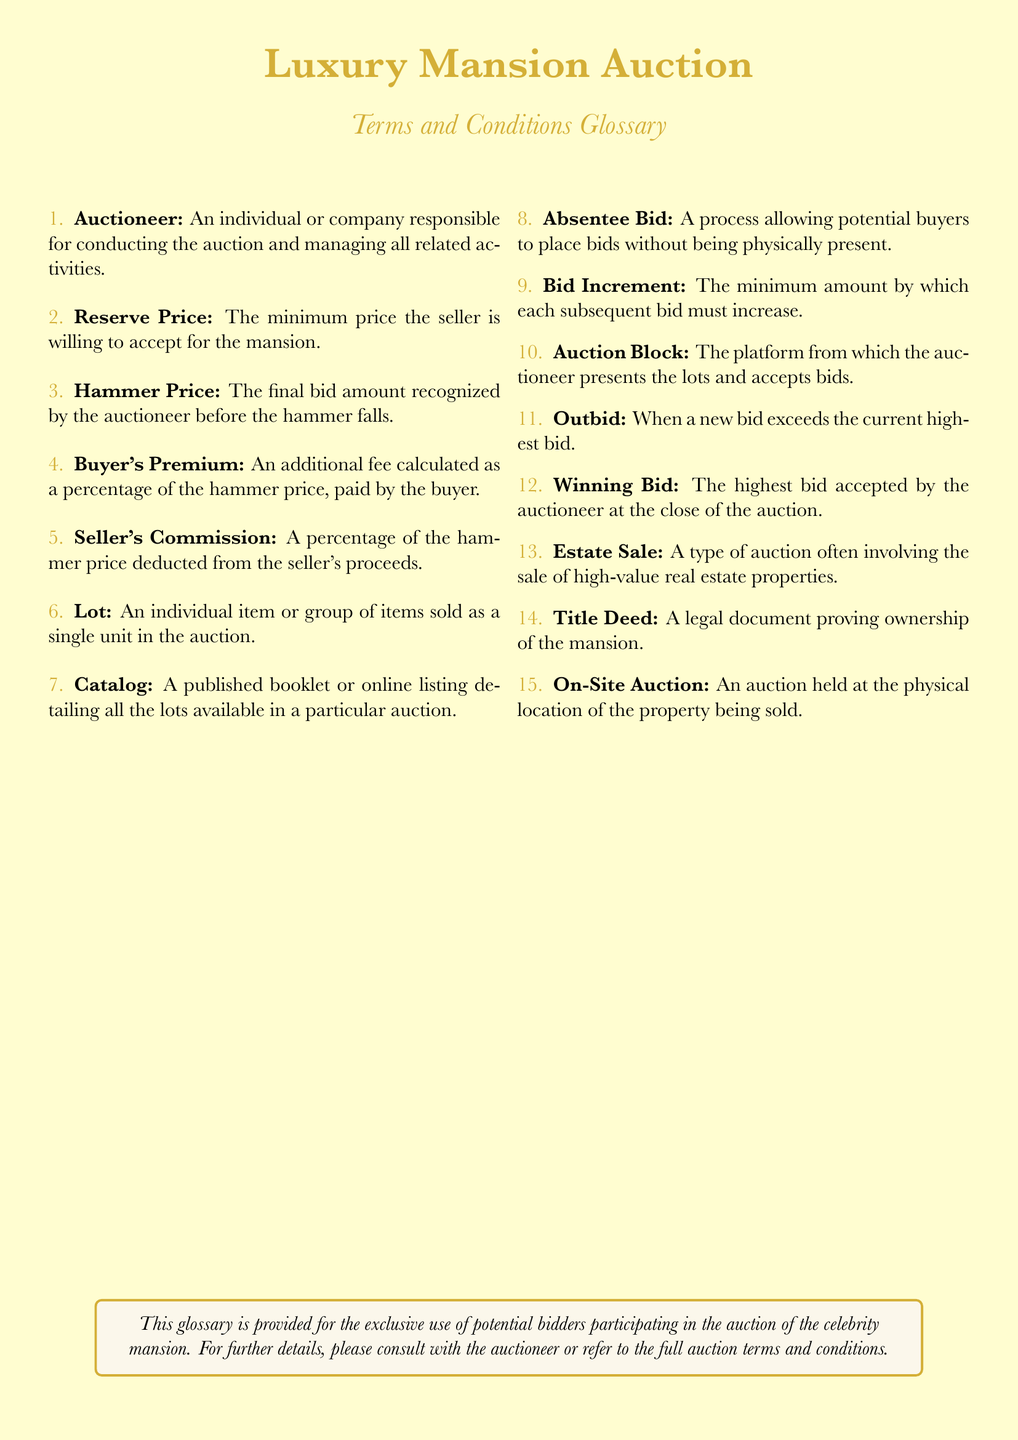What is the reserve price? The reserve price is defined as the minimum price the seller is willing to accept for the mansion.
Answer: Minimum price Who is responsible for conducting the auction? The auctioneer is the individual or company responsible for conducting the auction and managing all related activities.
Answer: Auctioneer What is the buyer's premium? The buyer's premium is an additional fee calculated as a percentage of the hammer price, paid by the buyer.
Answer: Additional fee What document proves ownership of the mansion? The title deed is the legal document that proves ownership of the mansion.
Answer: Title deed What is an absentee bid? An absentee bid allows potential buyers to place bids without being physically present.
Answer: Process to bid What is the auction block? The auction block is the platform from which the auctioneer presents the lots and accepts bids.
Answer: Auction platform How is the seller's commission calculated? The seller's commission is a percentage of the hammer price deducted from the seller's proceeds.
Answer: Percentage of hammer price What happens when a new bid exceeds the current highest bid? When a new bid exceeds the current highest bid, it is referred to as being outbid.
Answer: Outbid What is the winning bid? The winning bid is the highest bid accepted by the auctioneer at the close of the auction.
Answer: Highest bid 